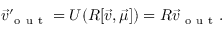Convert formula to latex. <formula><loc_0><loc_0><loc_500><loc_500>\vec { v } _ { o u t } ^ { \prime } = U ( R [ \vec { v } , \vec { \mu } ] ) = R \vec { v } _ { o u t } .</formula> 